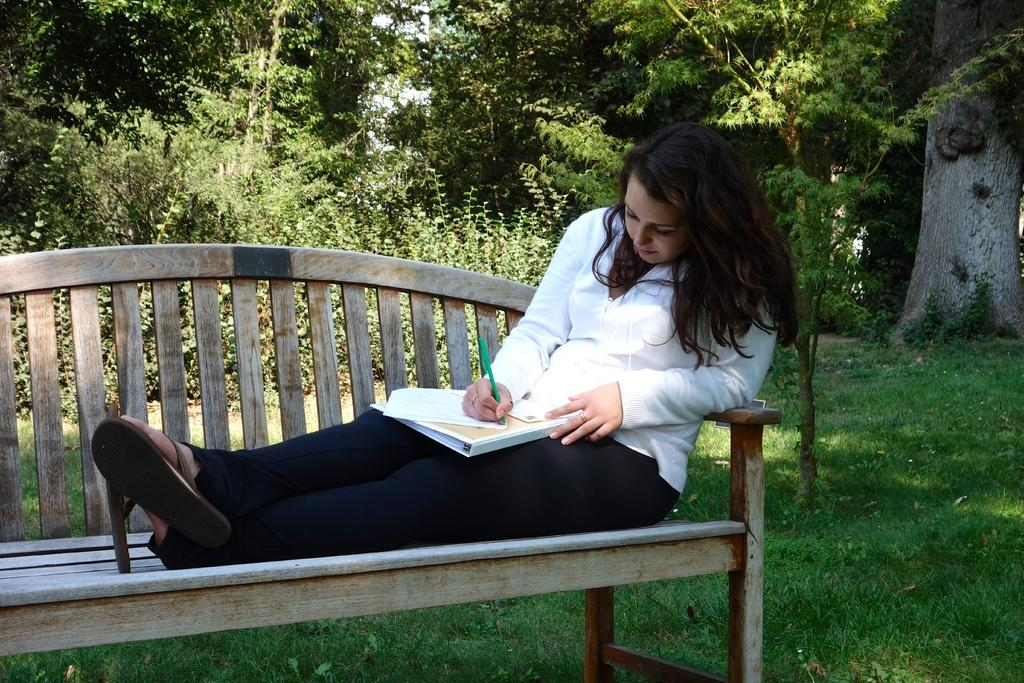Who is the main subject in the image? There is a woman in the image. What is the woman doing in the image? The woman is sitting on a bench and writing on a paper. Where is the bench located? The bench is located in a park. What can be seen in the background of the image? There are trees and plants in the background of the image. How many dogs are present in the image? There are no dogs visible in the image. What type of nut is the woman using to write on the paper? The woman is not using a nut to write on the paper; she is using a pen or pencil. 